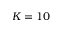Convert formula to latex. <formula><loc_0><loc_0><loc_500><loc_500>K = 1 0</formula> 